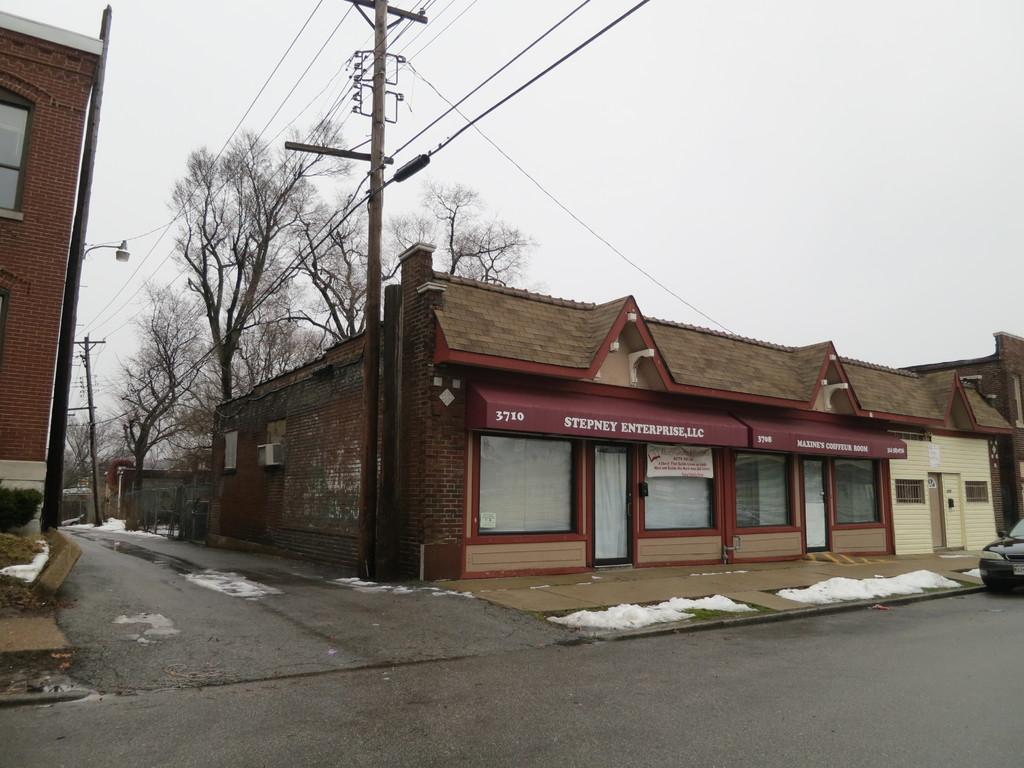What type of structures are present in the image? There are buildings in the image. What is located in front of the buildings? There is a road in front of the buildings. What can be seen in the background of the image? There are trees and the sky visible in the background of the image. What color is the balloon floating above the street in the image? There is no balloon or street present in the image. What type of weather can be seen in the image? The provided facts do not mention any weather conditions, so we cannot determine the weather from the image. 